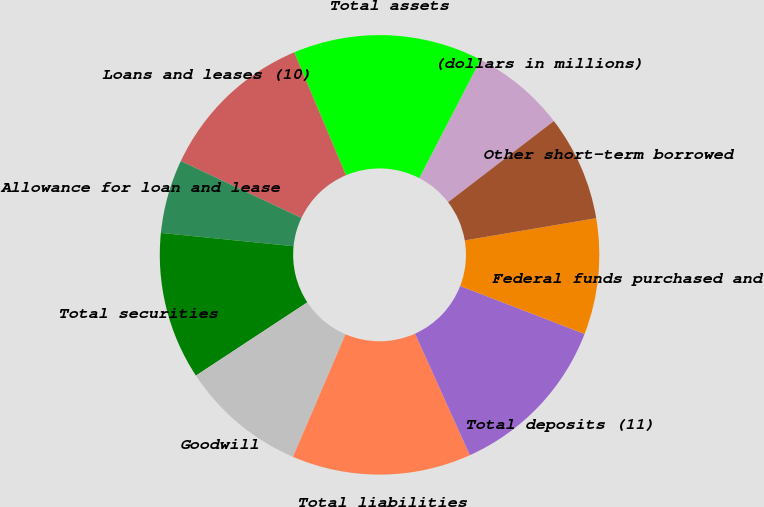Convert chart. <chart><loc_0><loc_0><loc_500><loc_500><pie_chart><fcel>(dollars in millions)<fcel>Total assets<fcel>Loans and leases (10)<fcel>Allowance for loan and lease<fcel>Total securities<fcel>Goodwill<fcel>Total liabilities<fcel>Total deposits (11)<fcel>Federal funds purchased and<fcel>Other short-term borrowed<nl><fcel>6.98%<fcel>13.95%<fcel>11.63%<fcel>5.43%<fcel>10.85%<fcel>9.3%<fcel>13.18%<fcel>12.4%<fcel>8.53%<fcel>7.75%<nl></chart> 